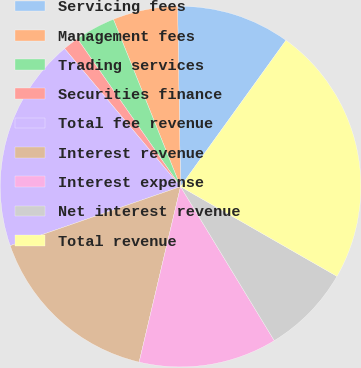Convert chart to OTSL. <chart><loc_0><loc_0><loc_500><loc_500><pie_chart><fcel>Servicing fees<fcel>Management fees<fcel>Trading services<fcel>Securities finance<fcel>Total fee revenue<fcel>Interest revenue<fcel>Interest expense<fcel>Net interest revenue<fcel>Total revenue<nl><fcel>10.2%<fcel>5.81%<fcel>3.62%<fcel>1.43%<fcel>19.19%<fcel>16.0%<fcel>12.39%<fcel>8.01%<fcel>23.35%<nl></chart> 